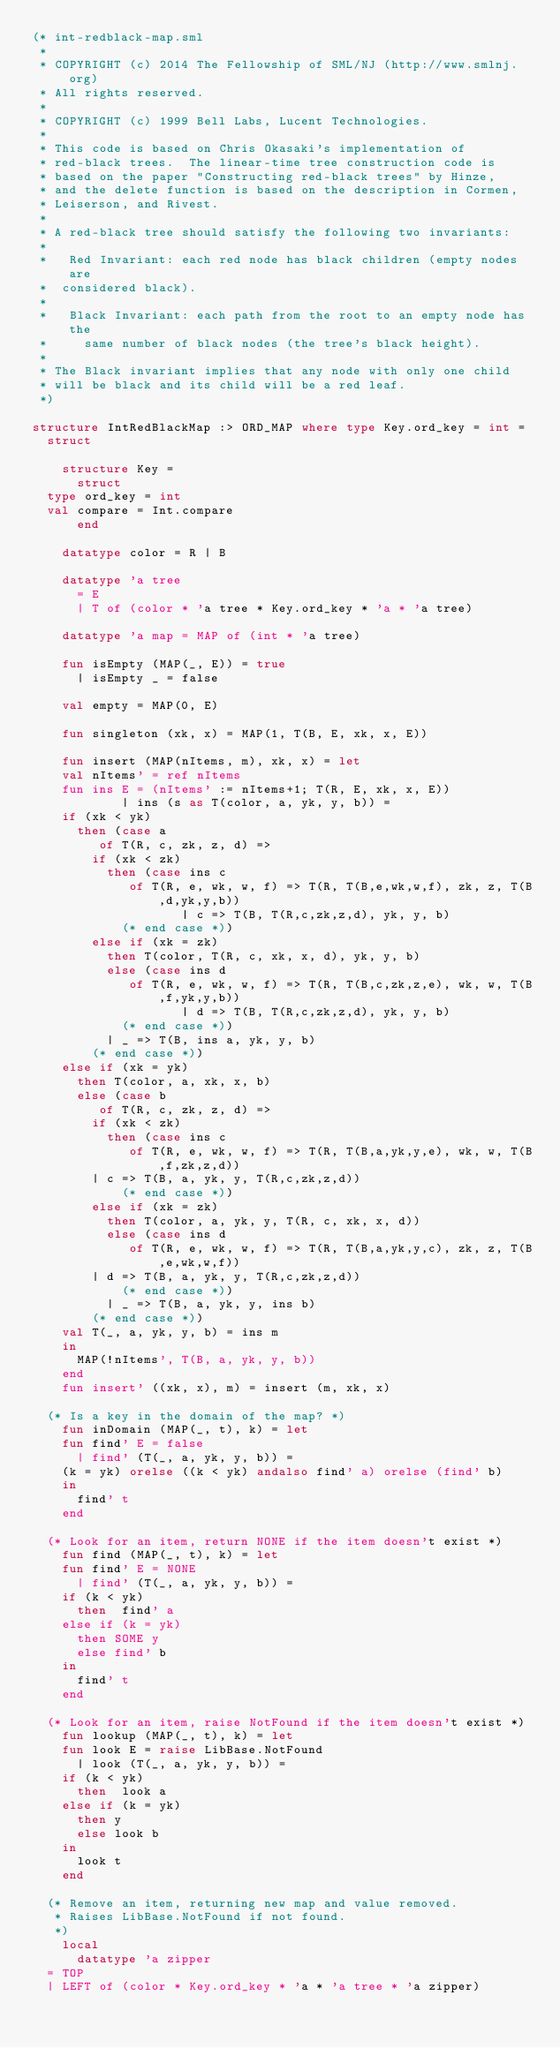<code> <loc_0><loc_0><loc_500><loc_500><_SML_>(* int-redblack-map.sml
 *
 * COPYRIGHT (c) 2014 The Fellowship of SML/NJ (http://www.smlnj.org)
 * All rights reserved.
 *
 * COPYRIGHT (c) 1999 Bell Labs, Lucent Technologies.
 *
 * This code is based on Chris Okasaki's implementation of
 * red-black trees.  The linear-time tree construction code is
 * based on the paper "Constructing red-black trees" by Hinze,
 * and the delete function is based on the description in Cormen,
 * Leiserson, and Rivest.
 *
 * A red-black tree should satisfy the following two invariants:
 *
 *   Red Invariant: each red node has black children (empty nodes are
 *	considered black).
 *
 *   Black Invariant: each path from the root to an empty node has the
 *     same number of black nodes (the tree's black height).
 *
 * The Black invariant implies that any node with only one child
 * will be black and its child will be a red leaf.
 *)

structure IntRedBlackMap :> ORD_MAP where type Key.ord_key = int =
  struct

    structure Key =
      struct
	type ord_key = int
	val compare = Int.compare
      end

    datatype color = R | B

    datatype 'a tree
      = E
      | T of (color * 'a tree * Key.ord_key * 'a * 'a tree)

    datatype 'a map = MAP of (int * 'a tree)

    fun isEmpty (MAP(_, E)) = true
      | isEmpty _ = false

    val empty = MAP(0, E)

    fun singleton (xk, x) = MAP(1, T(B, E, xk, x, E))

    fun insert (MAP(nItems, m), xk, x) = let
	  val nItems' = ref nItems
	  fun ins E = (nItems' := nItems+1; T(R, E, xk, x, E))
            | ins (s as T(color, a, yk, y, b)) =
		if (xk < yk)
		  then (case a
		     of T(R, c, zk, z, d) =>
			  if (xk < zk)
			    then (case ins c
			       of T(R, e, wk, w, f) => T(R, T(B,e,wk,w,f), zk, z, T(B,d,yk,y,b))
                		| c => T(B, T(R,c,zk,z,d), yk, y, b)
			      (* end case *))
			  else if (xk = zk)
			    then T(color, T(R, c, xk, x, d), yk, y, b)
			    else (case ins d
			       of T(R, e, wk, w, f) => T(R, T(B,c,zk,z,e), wk, w, T(B,f,yk,y,b))
                		| d => T(B, T(R,c,zk,z,d), yk, y, b)
			      (* end case *))
		      | _ => T(B, ins a, yk, y, b)
		    (* end case *))
		else if (xk = yk)
		  then T(color, a, xk, x, b)
		  else (case b
		     of T(R, c, zk, z, d) =>
			  if (xk < zk)
			    then (case ins c
			       of T(R, e, wk, w, f) => T(R, T(B,a,yk,y,e), wk, w, T(B,f,zk,z,d))
				| c => T(B, a, yk, y, T(R,c,zk,z,d))
			      (* end case *))
			  else if (xk = zk)
			    then T(color, a, yk, y, T(R, c, xk, x, d))
			    else (case ins d
			       of T(R, e, wk, w, f) => T(R, T(B,a,yk,y,c), zk, z, T(B,e,wk,w,f))
				| d => T(B, a, yk, y, T(R,c,zk,z,d))
			      (* end case *))
		      | _ => T(B, a, yk, y, ins b)
		    (* end case *))
	  val T(_, a, yk, y, b) = ins m
	  in
	    MAP(!nItems', T(B, a, yk, y, b))
	  end
    fun insert' ((xk, x), m) = insert (m, xk, x)

  (* Is a key in the domain of the map? *)
    fun inDomain (MAP(_, t), k) = let
	  fun find' E = false
	    | find' (T(_, a, yk, y, b)) =
		(k = yk) orelse ((k < yk) andalso find' a) orelse (find' b)
	  in
	    find' t
	  end

  (* Look for an item, return NONE if the item doesn't exist *)
    fun find (MAP(_, t), k) = let
	  fun find' E = NONE
	    | find' (T(_, a, yk, y, b)) =
		if (k < yk)
		  then  find' a
		else if (k = yk)
		  then SOME y
		  else find' b
	  in
	    find' t
	  end

  (* Look for an item, raise NotFound if the item doesn't exist *)
    fun lookup (MAP(_, t), k) = let
	  fun look E = raise LibBase.NotFound
	    | look (T(_, a, yk, y, b)) =
		if (k < yk)
		  then  look a
		else if (k = yk)
		  then y
		  else look b
	  in
	    look t
	  end

  (* Remove an item, returning new map and value removed.
   * Raises LibBase.NotFound if not found.
   *)
    local
      datatype 'a zipper
	= TOP
	| LEFT of (color * Key.ord_key * 'a * 'a tree * 'a zipper)</code> 